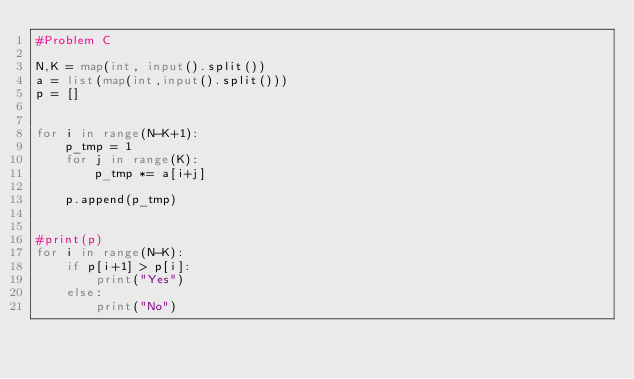Convert code to text. <code><loc_0><loc_0><loc_500><loc_500><_Python_>#Problem C

N,K = map(int, input().split())
a = list(map(int,input().split()))
p = []


for i in range(N-K+1):
    p_tmp = 1
    for j in range(K):
        p_tmp *= a[i+j]
    
    p.append(p_tmp)
    
        
#print(p)
for i in range(N-K):
    if p[i+1] > p[i]:
        print("Yes")
    else:
        print("No")</code> 